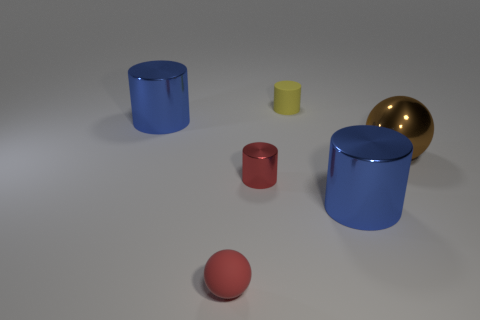Add 4 small shiny balls. How many objects exist? 10 Subtract all balls. How many objects are left? 4 Add 3 large shiny spheres. How many large shiny spheres exist? 4 Subtract 0 purple spheres. How many objects are left? 6 Subtract all large yellow matte things. Subtract all brown shiny objects. How many objects are left? 5 Add 3 big brown spheres. How many big brown spheres are left? 4 